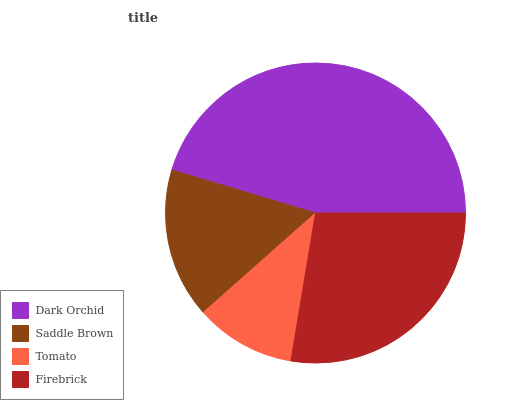Is Tomato the minimum?
Answer yes or no. Yes. Is Dark Orchid the maximum?
Answer yes or no. Yes. Is Saddle Brown the minimum?
Answer yes or no. No. Is Saddle Brown the maximum?
Answer yes or no. No. Is Dark Orchid greater than Saddle Brown?
Answer yes or no. Yes. Is Saddle Brown less than Dark Orchid?
Answer yes or no. Yes. Is Saddle Brown greater than Dark Orchid?
Answer yes or no. No. Is Dark Orchid less than Saddle Brown?
Answer yes or no. No. Is Firebrick the high median?
Answer yes or no. Yes. Is Saddle Brown the low median?
Answer yes or no. Yes. Is Saddle Brown the high median?
Answer yes or no. No. Is Firebrick the low median?
Answer yes or no. No. 